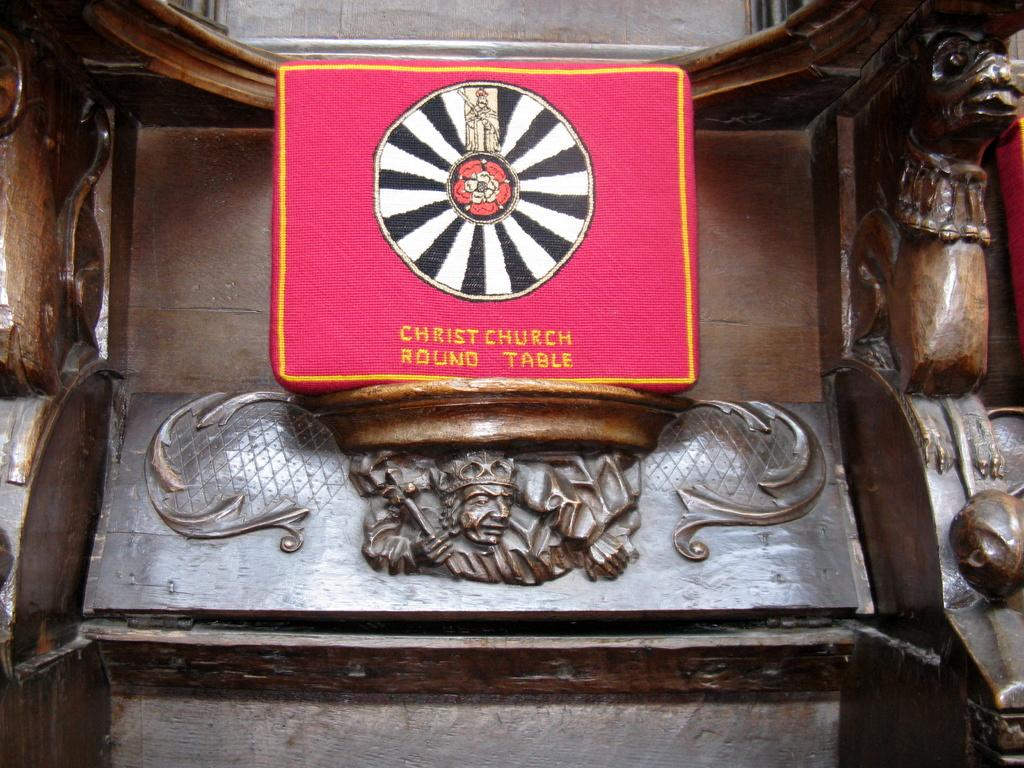What type of object in the image has carvings on it? There are carvings on a wooden object in the image. Can you describe the carvings on the wooden object? Unfortunately, the details of the carvings cannot be determined from the image alone. What material is the object with carvings made of? The object with carvings is made of wood. How many jellyfish can be seen swimming near the wooden object in the image? There are no jellyfish present in the image; it features a wooden object with carvings. What type of border surrounds the wooden object in the image? There is no border surrounding the wooden object in the image. 